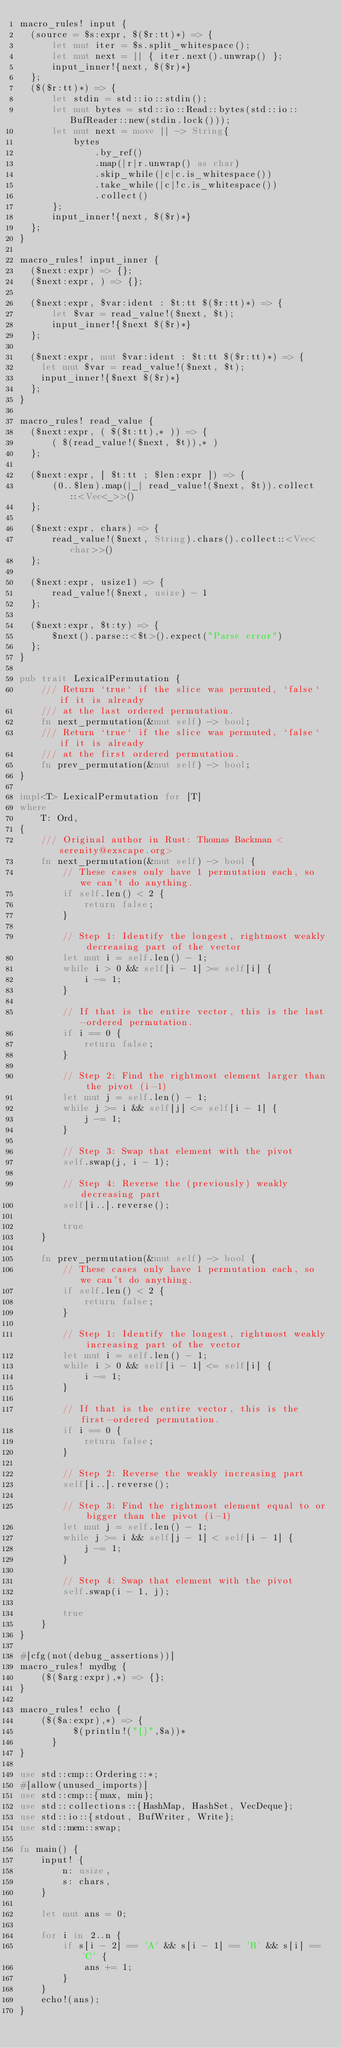<code> <loc_0><loc_0><loc_500><loc_500><_Rust_>macro_rules! input {
  (source = $s:expr, $($r:tt)*) => {
      let mut iter = $s.split_whitespace();
      let mut next = || { iter.next().unwrap() };
      input_inner!{next, $($r)*}
  };
  ($($r:tt)*) => {
      let stdin = std::io::stdin();
      let mut bytes = std::io::Read::bytes(std::io::BufReader::new(stdin.lock()));
      let mut next = move || -> String{
          bytes
              .by_ref()
              .map(|r|r.unwrap() as char)
              .skip_while(|c|c.is_whitespace())
              .take_while(|c|!c.is_whitespace())
              .collect()
      };
      input_inner!{next, $($r)*}
  };
}

macro_rules! input_inner {
  ($next:expr) => {};
  ($next:expr, ) => {};

  ($next:expr, $var:ident : $t:tt $($r:tt)*) => {
      let $var = read_value!($next, $t);
      input_inner!{$next $($r)*}
  };

  ($next:expr, mut $var:ident : $t:tt $($r:tt)*) => {
    let mut $var = read_value!($next, $t);
    input_inner!{$next $($r)*}
  };
}

macro_rules! read_value {
  ($next:expr, ( $($t:tt),* )) => {
      ( $(read_value!($next, $t)),* )
  };

  ($next:expr, [ $t:tt ; $len:expr ]) => {
      (0..$len).map(|_| read_value!($next, $t)).collect::<Vec<_>>()
  };

  ($next:expr, chars) => {
      read_value!($next, String).chars().collect::<Vec<char>>()
  };

  ($next:expr, usize1) => {
      read_value!($next, usize) - 1
  };

  ($next:expr, $t:ty) => {
      $next().parse::<$t>().expect("Parse error")
  };
}

pub trait LexicalPermutation {
    /// Return `true` if the slice was permuted, `false` if it is already
    /// at the last ordered permutation.
    fn next_permutation(&mut self) -> bool;
    /// Return `true` if the slice was permuted, `false` if it is already
    /// at the first ordered permutation.
    fn prev_permutation(&mut self) -> bool;
}

impl<T> LexicalPermutation for [T]
where
    T: Ord,
{
    /// Original author in Rust: Thomas Backman <serenity@exscape.org>
    fn next_permutation(&mut self) -> bool {
        // These cases only have 1 permutation each, so we can't do anything.
        if self.len() < 2 {
            return false;
        }

        // Step 1: Identify the longest, rightmost weakly decreasing part of the vector
        let mut i = self.len() - 1;
        while i > 0 && self[i - 1] >= self[i] {
            i -= 1;
        }

        // If that is the entire vector, this is the last-ordered permutation.
        if i == 0 {
            return false;
        }

        // Step 2: Find the rightmost element larger than the pivot (i-1)
        let mut j = self.len() - 1;
        while j >= i && self[j] <= self[i - 1] {
            j -= 1;
        }

        // Step 3: Swap that element with the pivot
        self.swap(j, i - 1);

        // Step 4: Reverse the (previously) weakly decreasing part
        self[i..].reverse();

        true
    }

    fn prev_permutation(&mut self) -> bool {
        // These cases only have 1 permutation each, so we can't do anything.
        if self.len() < 2 {
            return false;
        }

        // Step 1: Identify the longest, rightmost weakly increasing part of the vector
        let mut i = self.len() - 1;
        while i > 0 && self[i - 1] <= self[i] {
            i -= 1;
        }

        // If that is the entire vector, this is the first-ordered permutation.
        if i == 0 {
            return false;
        }

        // Step 2: Reverse the weakly increasing part
        self[i..].reverse();

        // Step 3: Find the rightmost element equal to or bigger than the pivot (i-1)
        let mut j = self.len() - 1;
        while j >= i && self[j - 1] < self[i - 1] {
            j -= 1;
        }

        // Step 4: Swap that element with the pivot
        self.swap(i - 1, j);

        true
    }
}

#[cfg(not(debug_assertions))]
macro_rules! mydbg {
    ($($arg:expr),*) => {};
}

macro_rules! echo {
    ($($a:expr),*) => {
          $(println!("{}",$a))*
      }
}

use std::cmp::Ordering::*;
#[allow(unused_imports)]
use std::cmp::{max, min};
use std::collections::{HashMap, HashSet, VecDeque};
use std::io::{stdout, BufWriter, Write};
use std::mem::swap;

fn main() {
    input! {
        n: usize,
        s: chars,
    }

    let mut ans = 0;

    for i in 2..n {
        if s[i - 2] == 'A' && s[i - 1] == 'B' && s[i] == 'C' {
            ans += 1;
        }
    }
    echo!(ans);
}</code> 